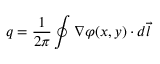Convert formula to latex. <formula><loc_0><loc_0><loc_500><loc_500>q = \frac { 1 } { 2 \pi } \oint \nabla \varphi ( x , y ) \cdot d \vec { l }</formula> 